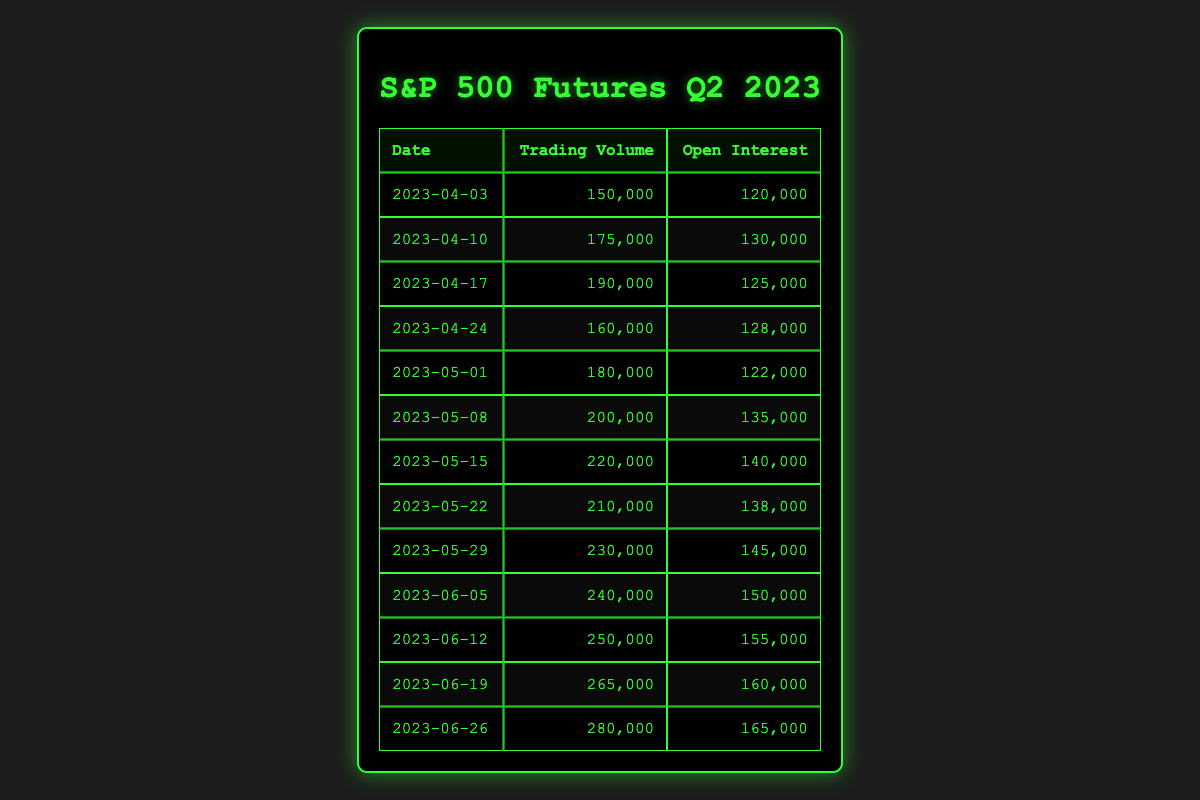What was the trading volume on April 24th? Referring to the table, the trading volume entry for April 24th lists 160,000.
Answer: 160,000 What is the open interest on June 12th? The table indicates that the open interest on June 12th is 155,000.
Answer: 155,000 Which date had the highest trading volume? By reviewing the trading volume values, June 26th has the highest trading volume at 280,000.
Answer: June 26th What was the average trading volume for May 2023? The trading volume for May consists of five entries: 180,000, 200,000, 220,000, 210,000, and 230,000. The sum is 1,040,000. The average is 1,040,000 divided by 5, which is 208,000.
Answer: 208,000 Was there an increase in open interest from April 3rd to April 10th? Open interest on April 3rd was 120,000, and on April 10th, it was 130,000, indicating an increase of 10,000. So, yes, it increased.
Answer: Yes On which date did the trading volume first exceed 200,000? Analyzing the trading volume, it first exceeds 200,000 on May 8th, when it reached 200,000 exactly.
Answer: May 8th What is the difference in open interest between April 17th and April 24th? The open interest on April 17th was 125,000 and on April 24th was 128,000. The difference is 128,000 minus 125,000, which equals 3,000.
Answer: 3,000 How many days did the trading volume exceed 250,000 in June? Looking at the trading volumes in June (240,000, 250,000, 265,000, and 280,000), there are three entries that exceed 250,000: 265,000 and 280,000, totaling 2 days.
Answer: 2 days Is the open interest greater on May 29th or June 5th? The open interest on May 29th was 145,000, while on June 5th, it was 150,000, indicating that June 5th had a greater open interest.
Answer: June 5th What was the total trading volume for the entire month of June? The trading volumes for June are 240,000, 250,000, 265,000, and 280,000. Their sum is 1,035,000. Therefore, the total trading volume for June is 1,035,000.
Answer: 1,035,000 Which dates see a decrease in open interest compared to the previous week? To identify decreases, compare weekly open interest values: April 10th (130,000) to April 17th (125,000) shows a decrease, and May 1st (122,000) to May 8th (135,000) shows increases. Hence, only April 10th to April 17th shows a decrease.
Answer: April 10th to April 17th 